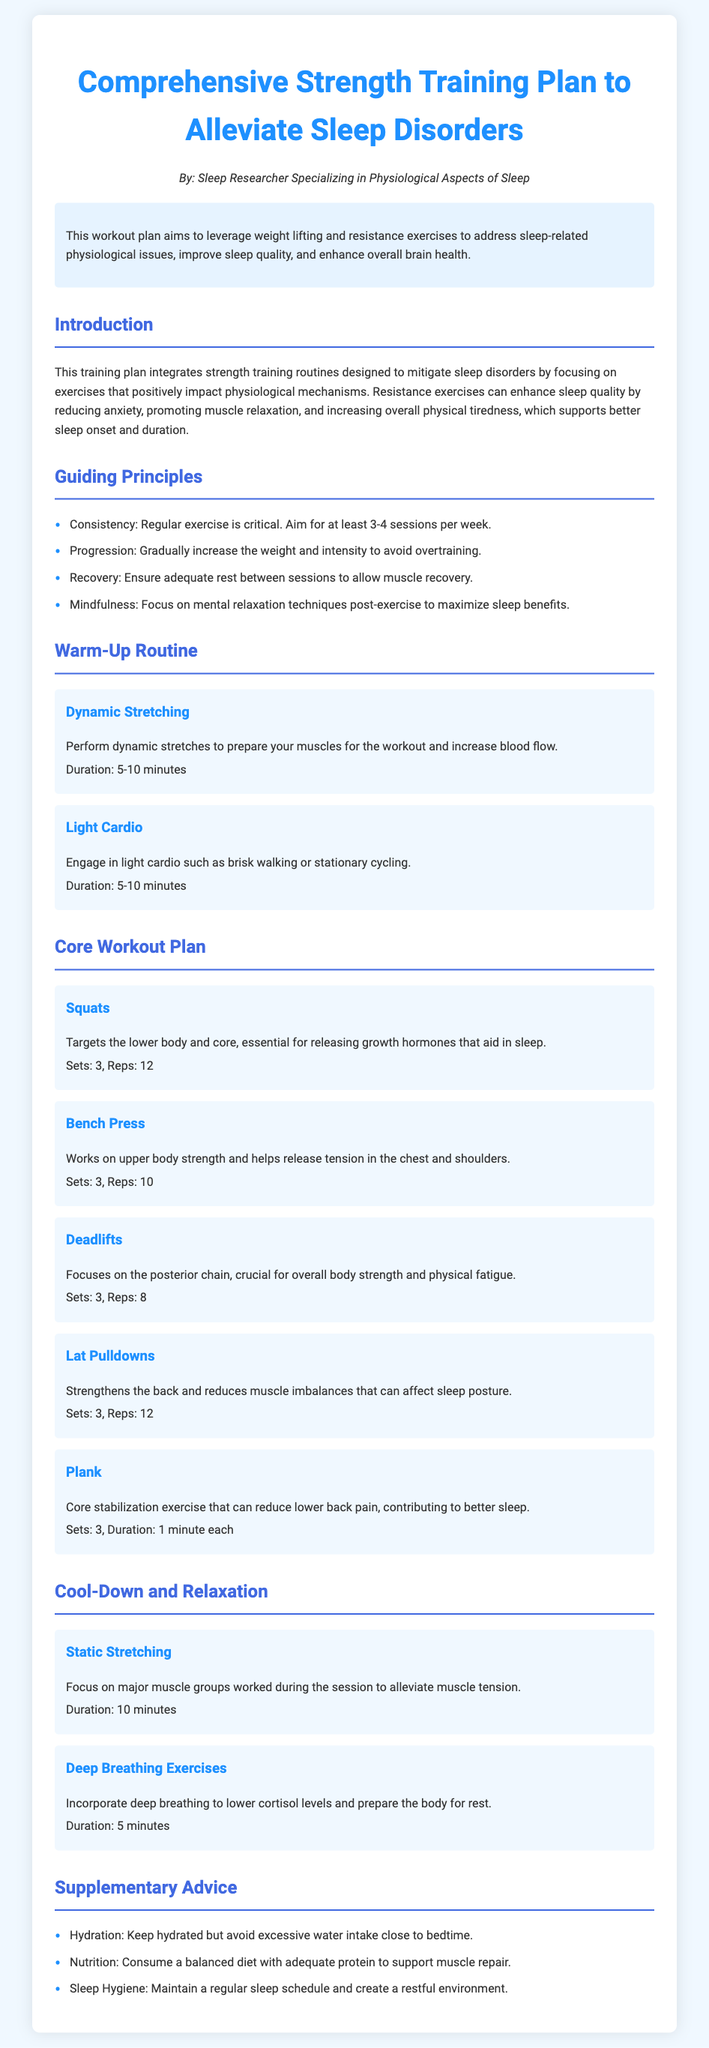What is the main purpose of the workout plan? The purpose of the workout plan is to leverage weight lifting and resistance exercises to address sleep-related physiological issues, improve sleep quality, and enhance overall brain health.
Answer: To alleviate sleep disorders How many sessions per week does the plan recommend? The plan recommends aiming for at least 3-4 sessions per week for effectiveness.
Answer: 3-4 sessions What type of exercise is suggested for warm-up? The document suggests dynamic stretching and light cardio as warm-up exercises to prepare the muscles.
Answer: Dynamic stretching and light cardio How long should the static stretching cool-down last? The static stretching should last for 10 minutes to help alleviate muscle tension after the workout.
Answer: 10 minutes What is the recommended duration for the Plank exercise? The Plank exercise is recommended to be held for 1 minute each during 3 sets for core stabilization.
Answer: 1 minute What is one of the supplementary advice regarding nutrition? The advice emphasizes consuming a balanced diet with adequate protein to support muscle repair necessary for recovery post-exercise.
Answer: Balanced diet with adequate protein What type of breathing exercises are recommended after exercising? The document recommends incorporating deep breathing exercises to lower cortisol levels and prepare the body for rest.
Answer: Deep breathing exercises Which muscle groups are the Squats targeting? Squats target the lower body and core, and are essential for releasing growth hormones that aid in sleep quality.
Answer: Lower body and core 